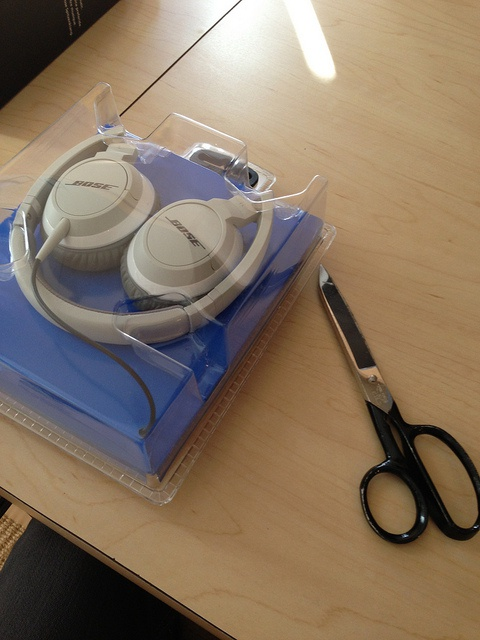Describe the objects in this image and their specific colors. I can see scissors in black and gray tones in this image. 